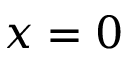Convert formula to latex. <formula><loc_0><loc_0><loc_500><loc_500>x = 0</formula> 